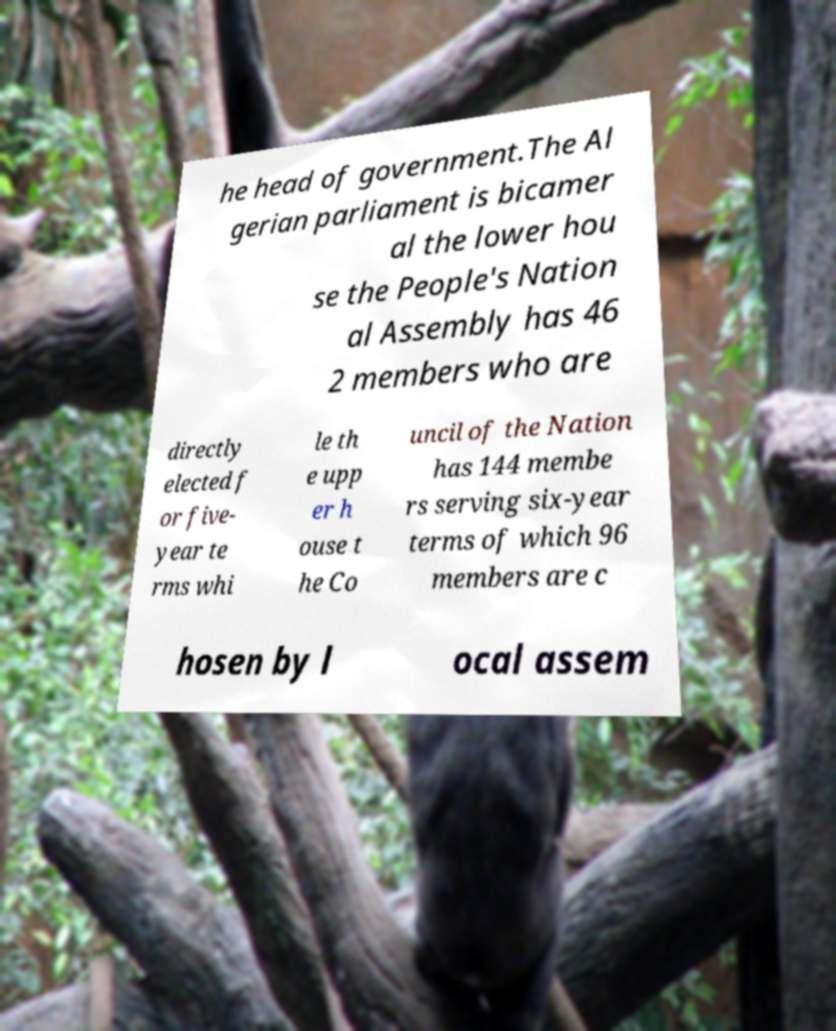For documentation purposes, I need the text within this image transcribed. Could you provide that? he head of government.The Al gerian parliament is bicamer al the lower hou se the People's Nation al Assembly has 46 2 members who are directly elected f or five- year te rms whi le th e upp er h ouse t he Co uncil of the Nation has 144 membe rs serving six-year terms of which 96 members are c hosen by l ocal assem 